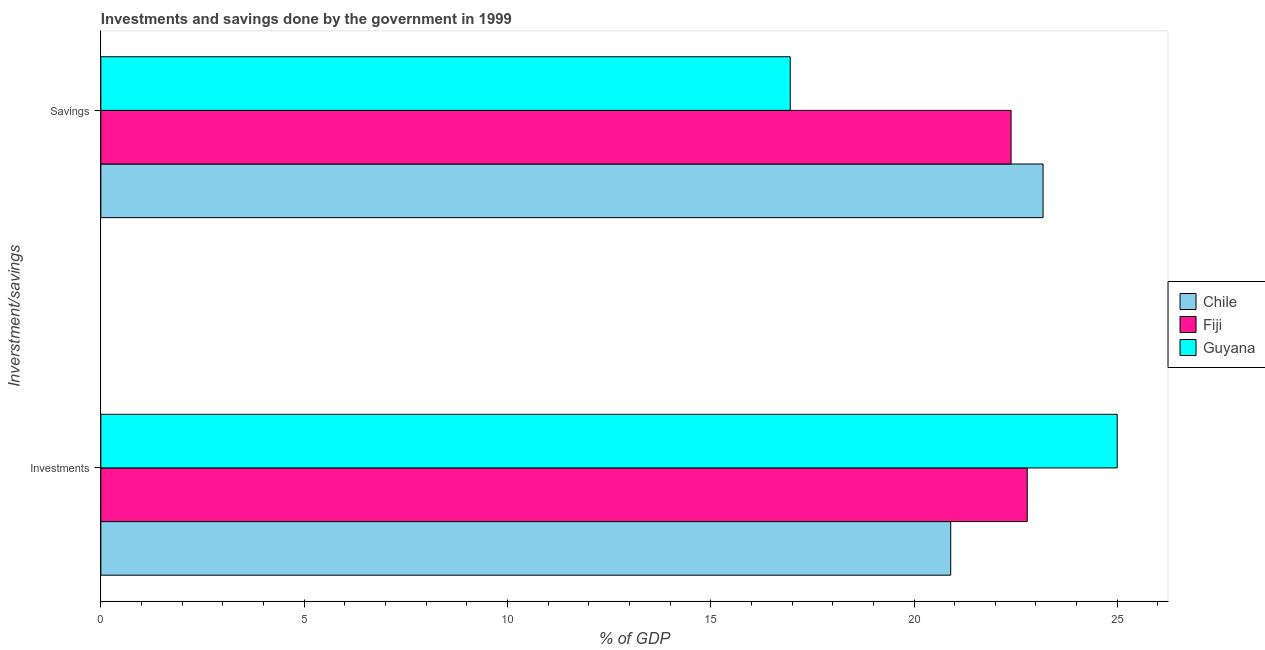How many different coloured bars are there?
Provide a short and direct response. 3. How many bars are there on the 1st tick from the top?
Provide a short and direct response. 3. How many bars are there on the 1st tick from the bottom?
Provide a succinct answer. 3. What is the label of the 1st group of bars from the top?
Make the answer very short. Savings. What is the savings of government in Chile?
Your answer should be very brief. 23.17. Across all countries, what is the maximum savings of government?
Give a very brief answer. 23.17. Across all countries, what is the minimum investments of government?
Provide a short and direct response. 20.9. In which country was the investments of government maximum?
Provide a succinct answer. Guyana. In which country was the investments of government minimum?
Your response must be concise. Chile. What is the total investments of government in the graph?
Give a very brief answer. 68.69. What is the difference between the investments of government in Chile and that in Guyana?
Make the answer very short. -4.1. What is the difference between the investments of government in Chile and the savings of government in Guyana?
Give a very brief answer. 3.95. What is the average savings of government per country?
Make the answer very short. 20.84. What is the difference between the savings of government and investments of government in Fiji?
Ensure brevity in your answer.  -0.4. In how many countries, is the savings of government greater than 25 %?
Your response must be concise. 0. What is the ratio of the savings of government in Chile to that in Fiji?
Offer a very short reply. 1.04. In how many countries, is the investments of government greater than the average investments of government taken over all countries?
Offer a terse response. 1. What does the 3rd bar from the bottom in Savings represents?
Give a very brief answer. Guyana. How many bars are there?
Provide a succinct answer. 6. What is the difference between two consecutive major ticks on the X-axis?
Make the answer very short. 5. Are the values on the major ticks of X-axis written in scientific E-notation?
Keep it short and to the point. No. Does the graph contain grids?
Ensure brevity in your answer.  No. Where does the legend appear in the graph?
Give a very brief answer. Center right. How many legend labels are there?
Offer a terse response. 3. What is the title of the graph?
Provide a short and direct response. Investments and savings done by the government in 1999. What is the label or title of the X-axis?
Your answer should be compact. % of GDP. What is the label or title of the Y-axis?
Give a very brief answer. Inverstment/savings. What is the % of GDP of Chile in Investments?
Your answer should be very brief. 20.9. What is the % of GDP in Fiji in Investments?
Provide a succinct answer. 22.79. What is the % of GDP in Guyana in Investments?
Provide a succinct answer. 25. What is the % of GDP in Chile in Savings?
Provide a succinct answer. 23.17. What is the % of GDP of Fiji in Savings?
Provide a succinct answer. 22.39. What is the % of GDP of Guyana in Savings?
Make the answer very short. 16.96. Across all Inverstment/savings, what is the maximum % of GDP in Chile?
Your response must be concise. 23.17. Across all Inverstment/savings, what is the maximum % of GDP in Fiji?
Make the answer very short. 22.79. Across all Inverstment/savings, what is the maximum % of GDP of Guyana?
Keep it short and to the point. 25. Across all Inverstment/savings, what is the minimum % of GDP in Chile?
Ensure brevity in your answer.  20.9. Across all Inverstment/savings, what is the minimum % of GDP of Fiji?
Your answer should be compact. 22.39. Across all Inverstment/savings, what is the minimum % of GDP of Guyana?
Provide a short and direct response. 16.96. What is the total % of GDP of Chile in the graph?
Your response must be concise. 44.08. What is the total % of GDP of Fiji in the graph?
Your answer should be very brief. 45.17. What is the total % of GDP in Guyana in the graph?
Keep it short and to the point. 41.95. What is the difference between the % of GDP of Chile in Investments and that in Savings?
Ensure brevity in your answer.  -2.27. What is the difference between the % of GDP in Fiji in Investments and that in Savings?
Give a very brief answer. 0.4. What is the difference between the % of GDP of Guyana in Investments and that in Savings?
Offer a terse response. 8.04. What is the difference between the % of GDP of Chile in Investments and the % of GDP of Fiji in Savings?
Give a very brief answer. -1.49. What is the difference between the % of GDP of Chile in Investments and the % of GDP of Guyana in Savings?
Offer a terse response. 3.95. What is the difference between the % of GDP in Fiji in Investments and the % of GDP in Guyana in Savings?
Provide a short and direct response. 5.83. What is the average % of GDP in Chile per Inverstment/savings?
Offer a terse response. 22.04. What is the average % of GDP of Fiji per Inverstment/savings?
Give a very brief answer. 22.59. What is the average % of GDP in Guyana per Inverstment/savings?
Provide a succinct answer. 20.98. What is the difference between the % of GDP in Chile and % of GDP in Fiji in Investments?
Make the answer very short. -1.88. What is the difference between the % of GDP of Chile and % of GDP of Guyana in Investments?
Provide a succinct answer. -4.1. What is the difference between the % of GDP in Fiji and % of GDP in Guyana in Investments?
Ensure brevity in your answer.  -2.21. What is the difference between the % of GDP in Chile and % of GDP in Fiji in Savings?
Give a very brief answer. 0.79. What is the difference between the % of GDP of Chile and % of GDP of Guyana in Savings?
Offer a very short reply. 6.22. What is the difference between the % of GDP of Fiji and % of GDP of Guyana in Savings?
Your response must be concise. 5.43. What is the ratio of the % of GDP in Chile in Investments to that in Savings?
Make the answer very short. 0.9. What is the ratio of the % of GDP in Fiji in Investments to that in Savings?
Provide a succinct answer. 1.02. What is the ratio of the % of GDP of Guyana in Investments to that in Savings?
Offer a very short reply. 1.47. What is the difference between the highest and the second highest % of GDP of Chile?
Your response must be concise. 2.27. What is the difference between the highest and the second highest % of GDP in Fiji?
Keep it short and to the point. 0.4. What is the difference between the highest and the second highest % of GDP in Guyana?
Your answer should be very brief. 8.04. What is the difference between the highest and the lowest % of GDP in Chile?
Keep it short and to the point. 2.27. What is the difference between the highest and the lowest % of GDP of Fiji?
Provide a short and direct response. 0.4. What is the difference between the highest and the lowest % of GDP of Guyana?
Give a very brief answer. 8.04. 